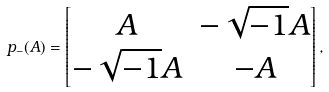Convert formula to latex. <formula><loc_0><loc_0><loc_500><loc_500>p _ { - } ( A ) = \begin{bmatrix} A & - \sqrt { - 1 } A \\ - \sqrt { - 1 } A & - A \end{bmatrix} ,</formula> 